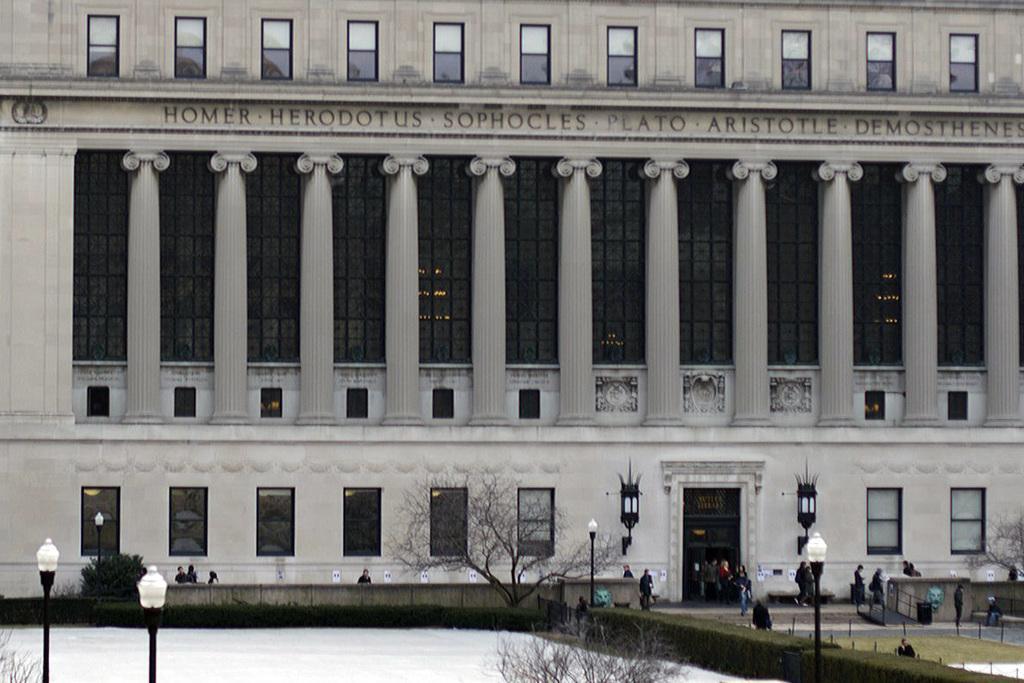In one or two sentences, can you explain what this image depicts? In the foreground of the picture there are street lights, trees, plants, people, wall and other objects. In the center of the picture there is a building with huge pillars, windows and door. 